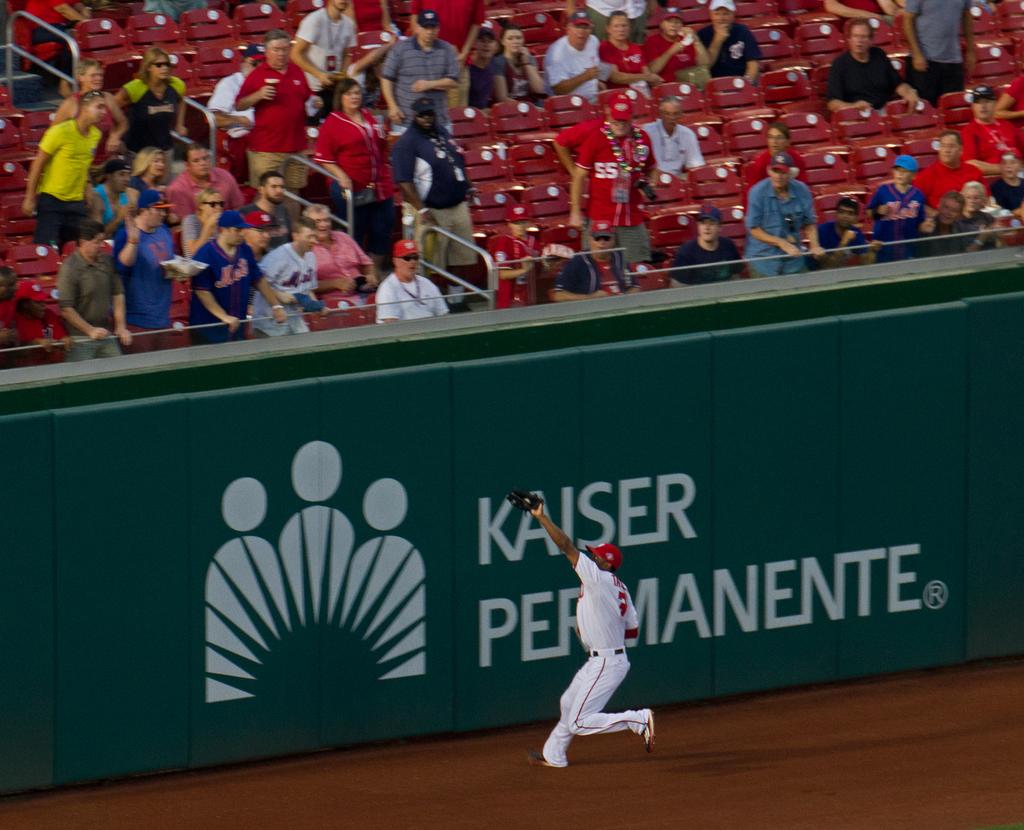What is the brand with the "all rights reserved " symbol right next to it?
Your response must be concise. Kaiser permanente. 